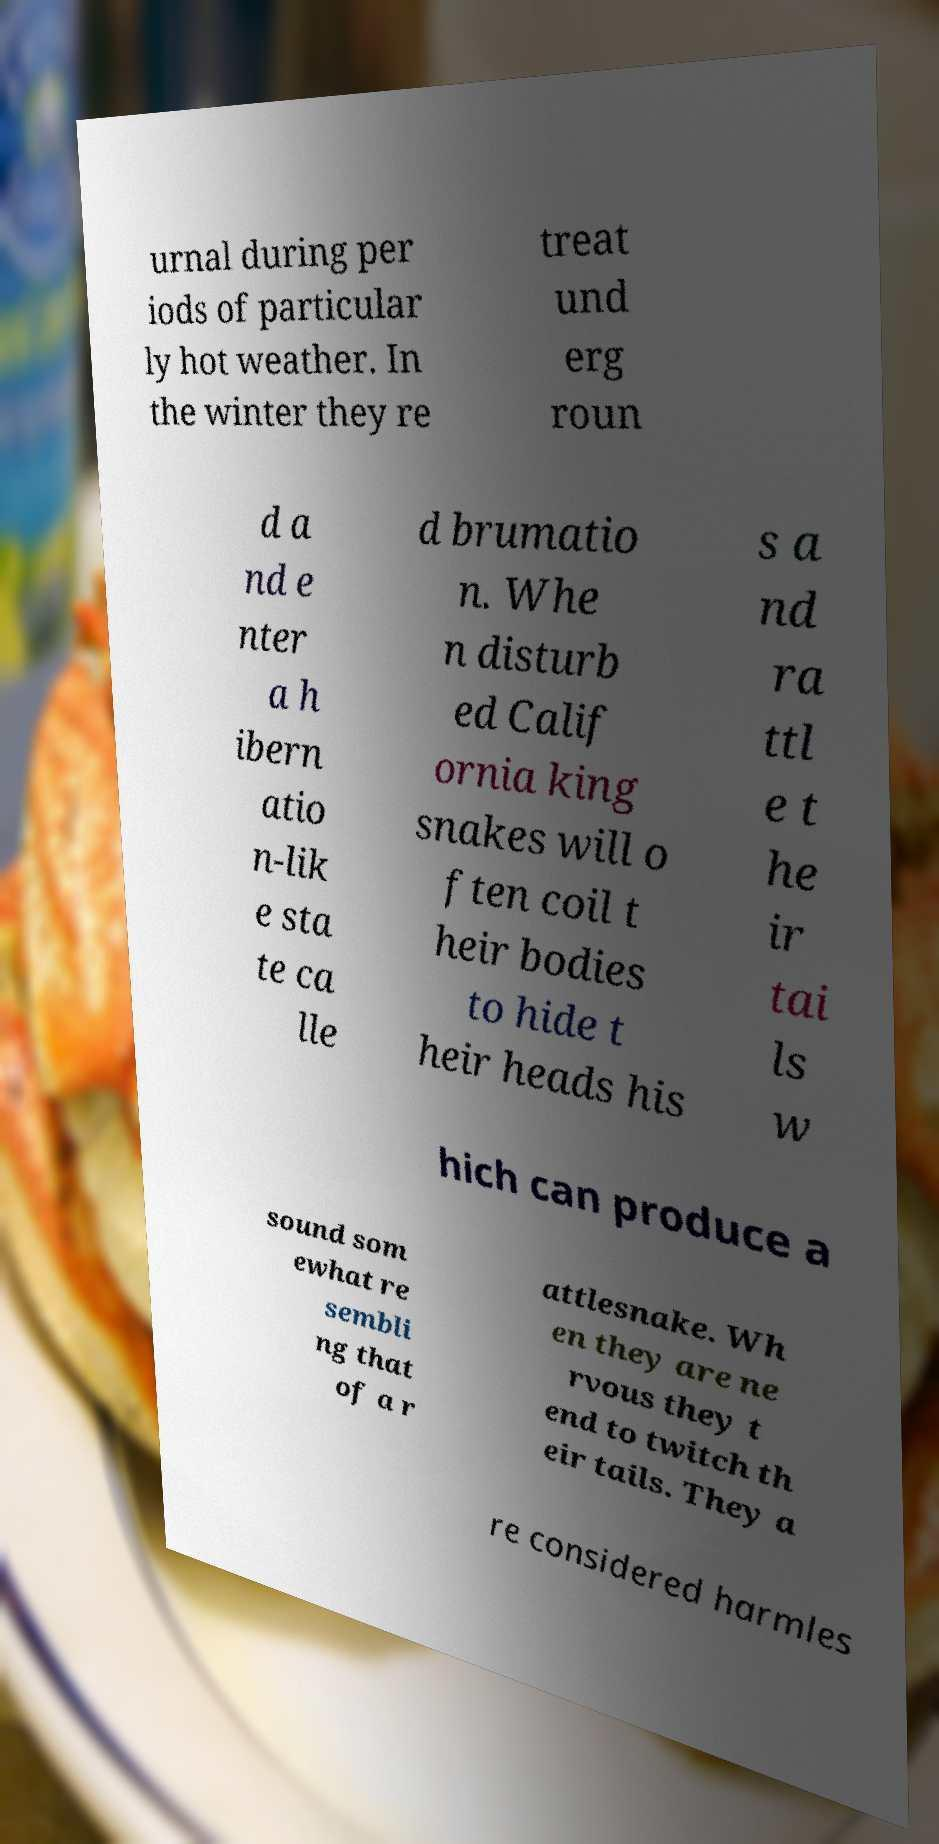Please identify and transcribe the text found in this image. urnal during per iods of particular ly hot weather. In the winter they re treat und erg roun d a nd e nter a h ibern atio n-lik e sta te ca lle d brumatio n. Whe n disturb ed Calif ornia king snakes will o ften coil t heir bodies to hide t heir heads his s a nd ra ttl e t he ir tai ls w hich can produce a sound som ewhat re sembli ng that of a r attlesnake. Wh en they are ne rvous they t end to twitch th eir tails. They a re considered harmles 